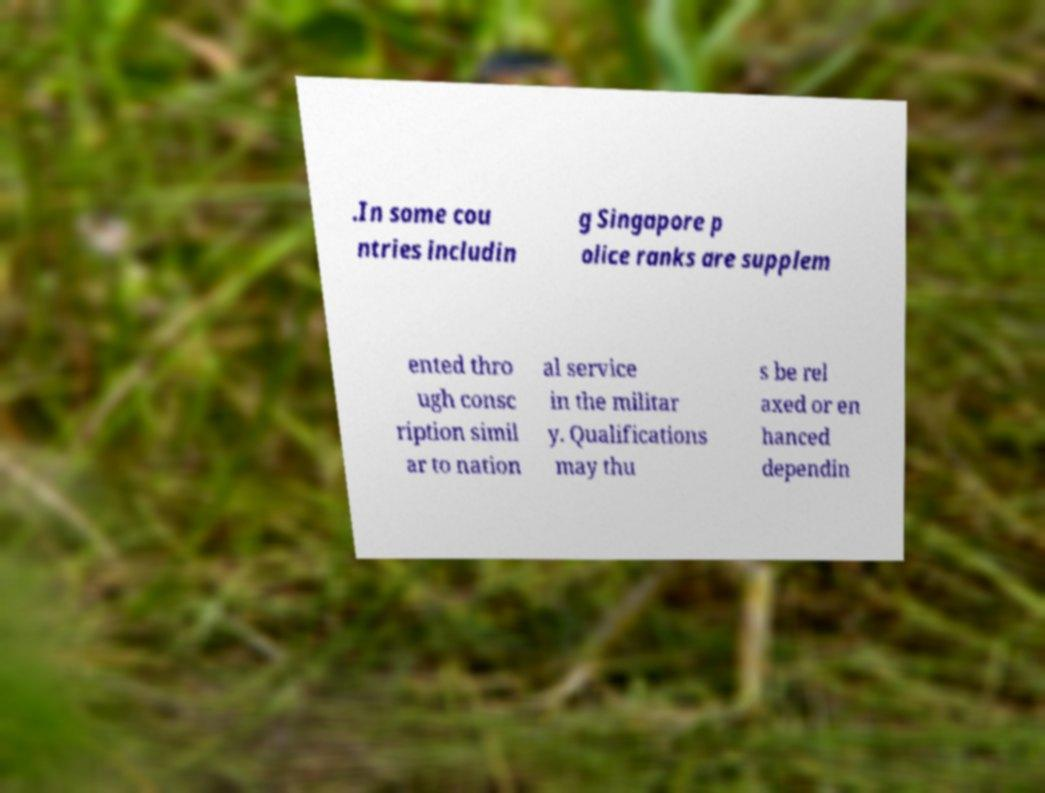Can you read and provide the text displayed in the image?This photo seems to have some interesting text. Can you extract and type it out for me? .In some cou ntries includin g Singapore p olice ranks are supplem ented thro ugh consc ription simil ar to nation al service in the militar y. Qualifications may thu s be rel axed or en hanced dependin 